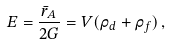<formula> <loc_0><loc_0><loc_500><loc_500>E = \frac { \bar { r } _ { A } } { 2 G } = V ( \rho _ { d } + \rho _ { f } ) \, ,</formula> 